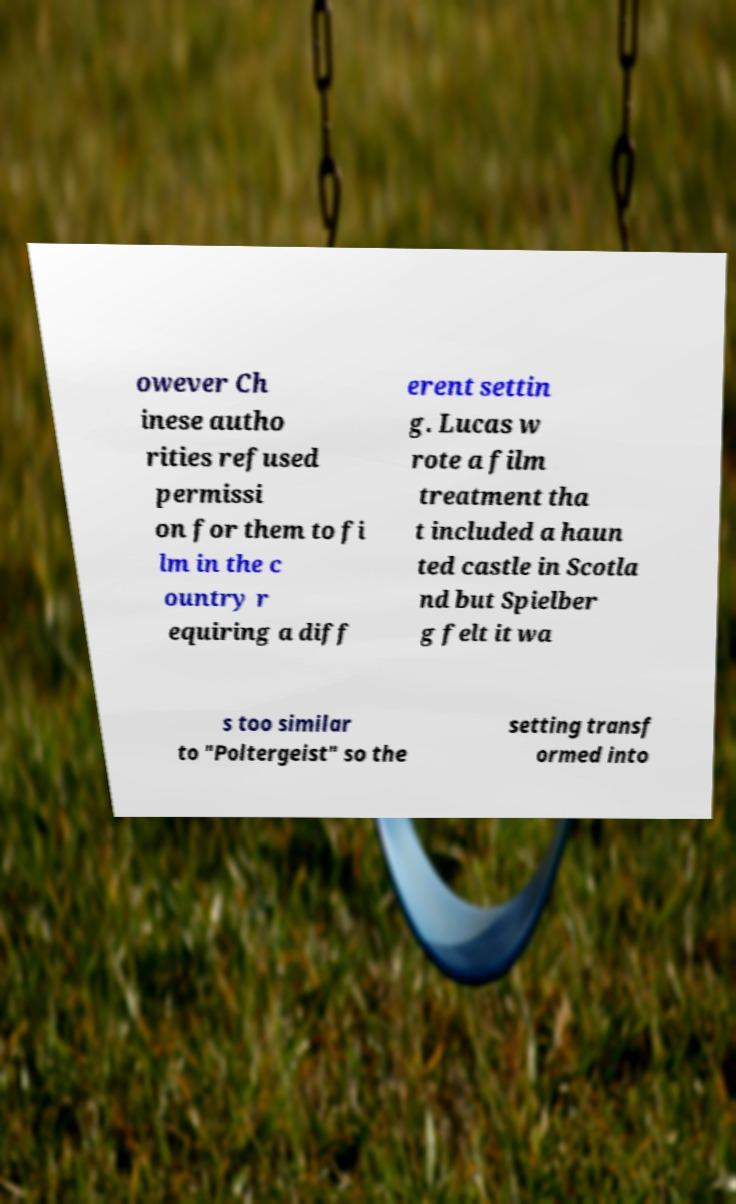Can you accurately transcribe the text from the provided image for me? owever Ch inese autho rities refused permissi on for them to fi lm in the c ountry r equiring a diff erent settin g. Lucas w rote a film treatment tha t included a haun ted castle in Scotla nd but Spielber g felt it wa s too similar to "Poltergeist" so the setting transf ormed into 